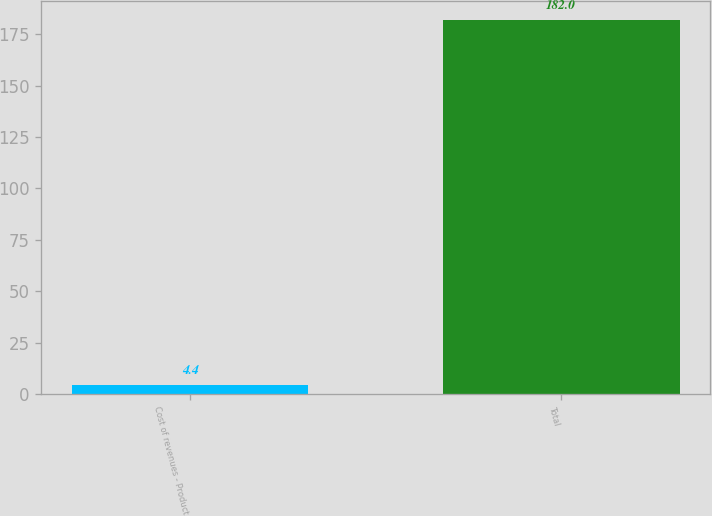Convert chart to OTSL. <chart><loc_0><loc_0><loc_500><loc_500><bar_chart><fcel>Cost of revenues - Product<fcel>Total<nl><fcel>4.4<fcel>182<nl></chart> 